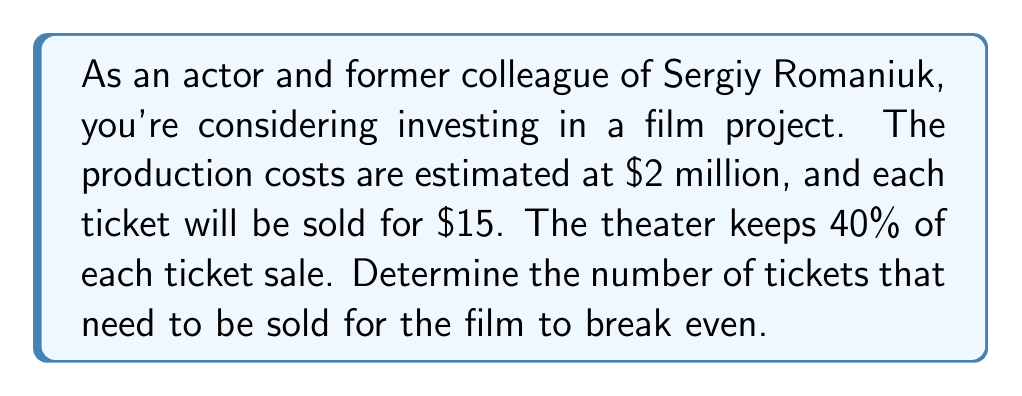Show me your answer to this math problem. Let's approach this step-by-step:

1) First, let's define our variables:
   Let $x$ be the number of tickets sold

2) Now, let's set up our equation:
   Revenue = Fixed Costs + Variable Costs

3) In this case:
   - Fixed Costs = $2,000,000 (production costs)
   - Revenue per ticket = $15 * 0.6 = $9 (since the theater keeps 40%)
   - There are no variable costs mentioned

4) Our break-even equation is:
   $9x = 2,000,000$

5) Solving for $x$:
   $$x = \frac{2,000,000}{9} = 222,222.22$$

6) Since we can't sell a fraction of a ticket, we round up to the nearest whole number.
Answer: 222,223 tickets 